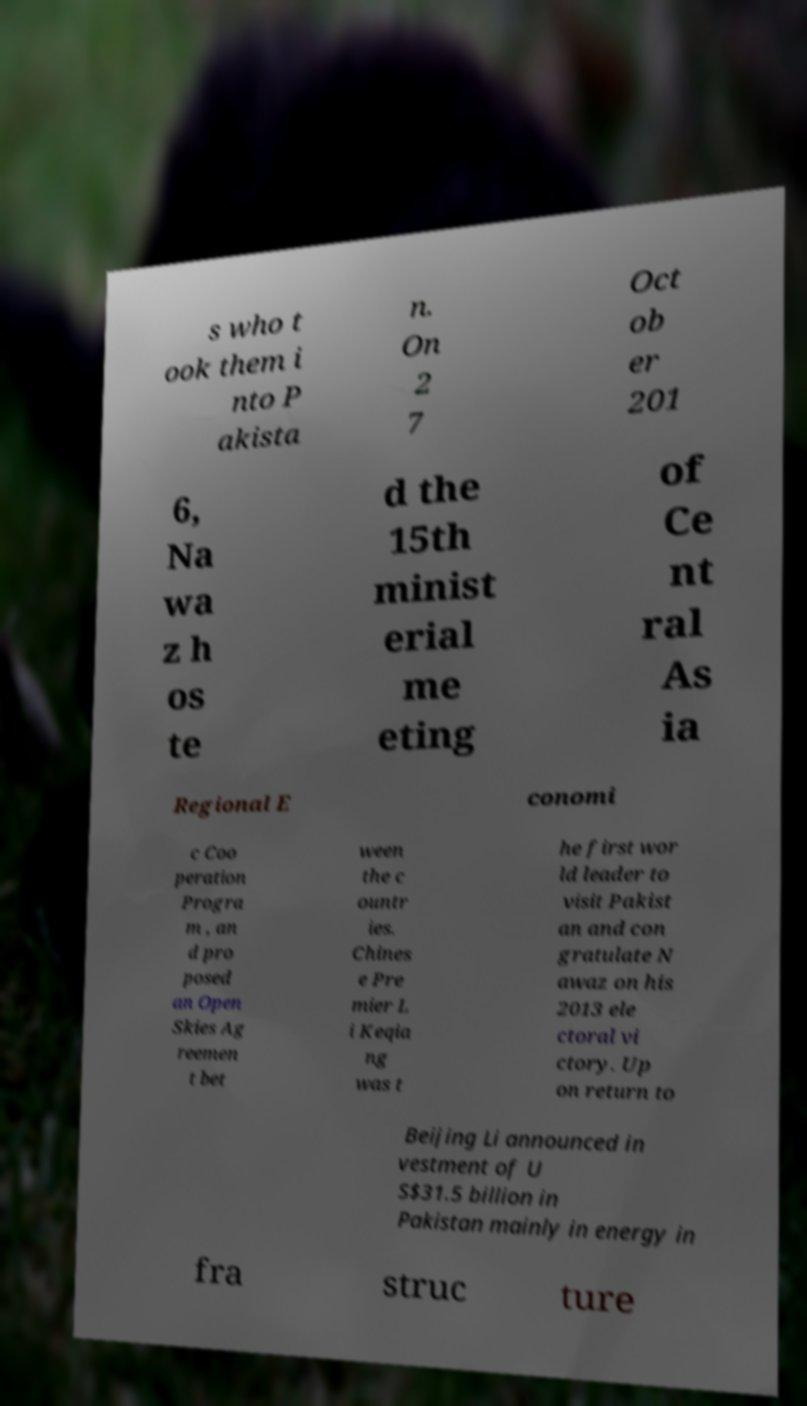Please read and relay the text visible in this image. What does it say? s who t ook them i nto P akista n. On 2 7 Oct ob er 201 6, Na wa z h os te d the 15th minist erial me eting of Ce nt ral As ia Regional E conomi c Coo peration Progra m , an d pro posed an Open Skies Ag reemen t bet ween the c ountr ies. Chines e Pre mier L i Keqia ng was t he first wor ld leader to visit Pakist an and con gratulate N awaz on his 2013 ele ctoral vi ctory. Up on return to Beijing Li announced in vestment of U S$31.5 billion in Pakistan mainly in energy in fra struc ture 